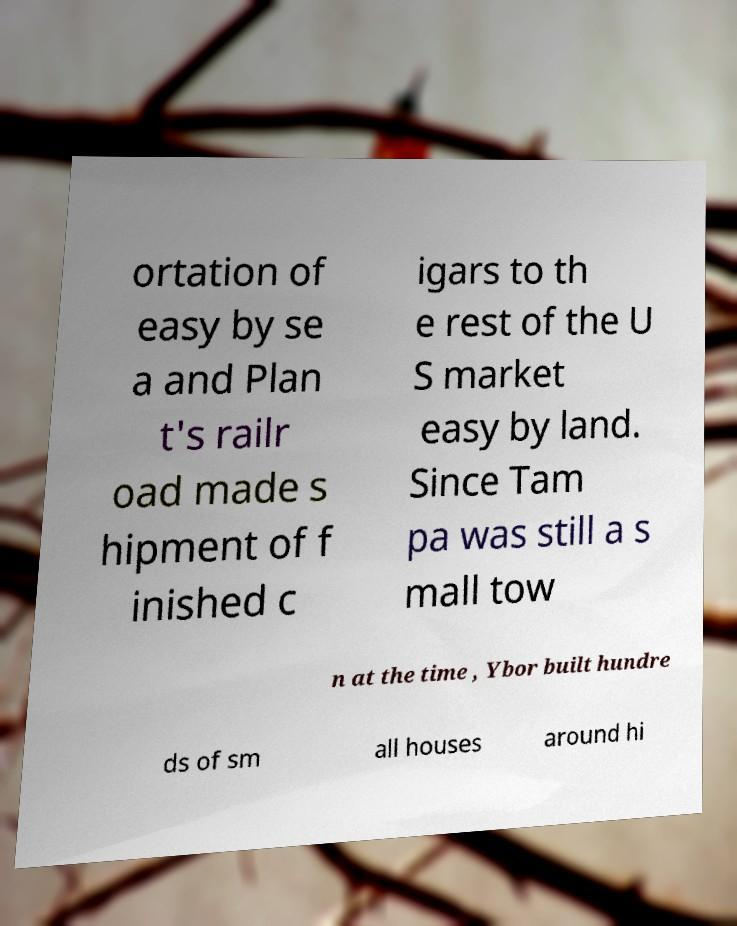Please identify and transcribe the text found in this image. ortation of easy by se a and Plan t's railr oad made s hipment of f inished c igars to th e rest of the U S market easy by land. Since Tam pa was still a s mall tow n at the time , Ybor built hundre ds of sm all houses around hi 